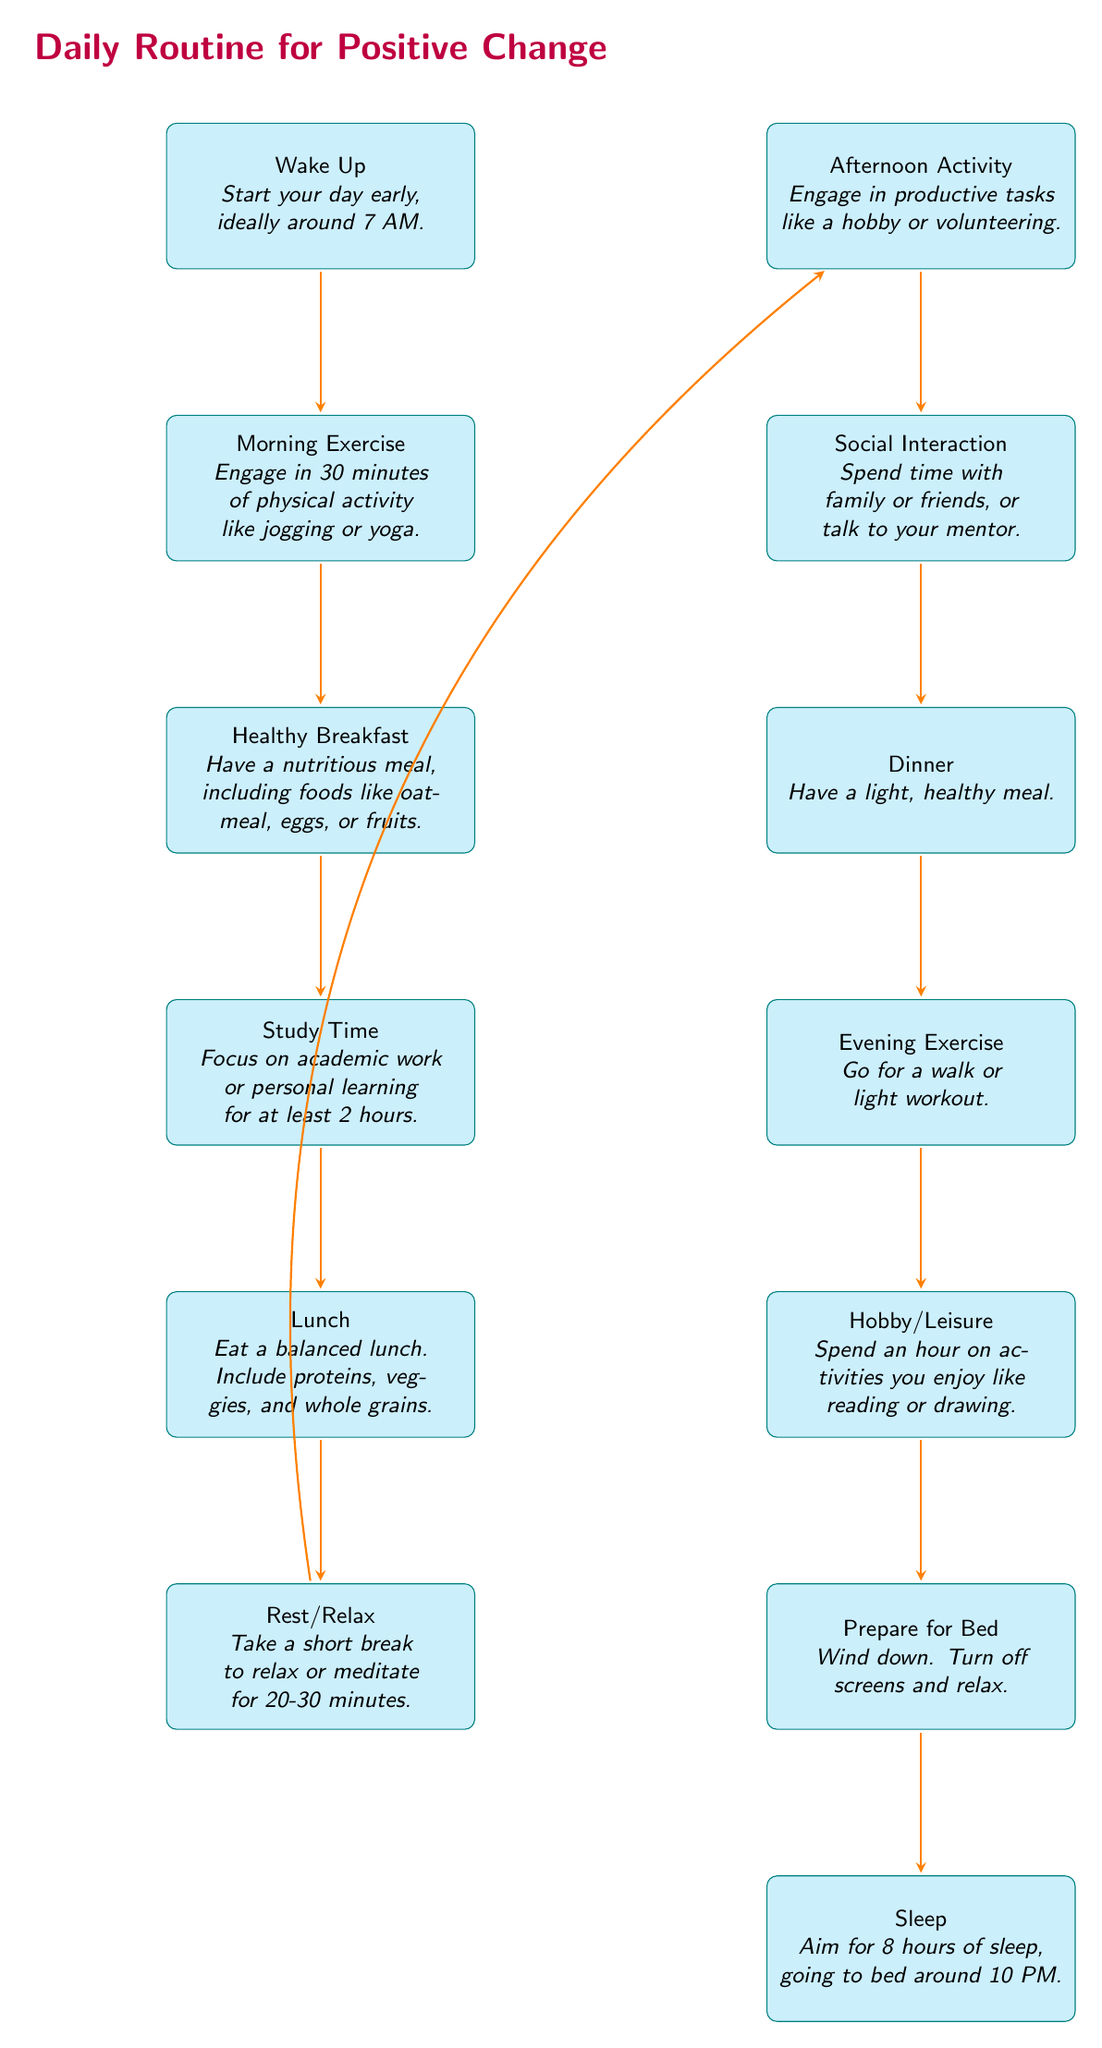What is the first activity you do after waking up? The first activity listed in the diagram after "Wake Up" is "Morning Exercise." The diagram clearly indicates that after you wake up, you proceed to do morning exercise as the next step.
Answer: Morning Exercise How many total nodes are in the diagram? To find the total number of nodes, count each box in the diagram. The nodes are: Wake Up, Morning Exercise, Healthy Breakfast, Study Time, Lunch, Rest/Relax, Afternoon Activity, Social Interaction, Dinner, Evening Exercise, Hobby/Leisure, Prepare for Bed, Sleep. There are 13 nodes in total.
Answer: 13 What do you do after having lunch? After "Lunch," the next step listed is "Rest/Relax." The diagram shows a directional flow from Lunch directly to Rest/Relax.
Answer: Rest/Relax How many hours of study time are recommended? The diagram specifies "at least 2 hours" for study time. By directly referring to the "Study Time" node, we identify this value clearly.
Answer: 2 hours What is the last activity in the daily routine? The last activity indicated in the diagram is "Sleep." This is shown at the bottom of the diagram, concluding the daily routine flow.
Answer: Sleep What activity follows social interaction? Following "Social Interaction," the next activity listed is "Dinner." The diagram shows a direct arrow pointing from Social Interaction to Dinner.
Answer: Dinner If you want to exercise in the morning, which step must you complete first? You must complete the "Wake Up" step first. The diagram shows "Wake Up" as the initial activity, and only after waking can you engage in morning exercise.
Answer: Wake Up What type of meal is suggested for breakfast? The diagram suggests "Healthy Breakfast," which includes foods like oatmeal, eggs, or fruits. This specific information is noted directly under the breakfast node in the diagram.
Answer: Healthy Breakfast 